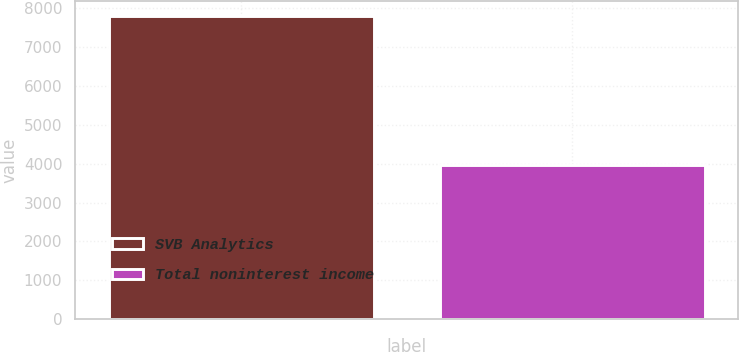Convert chart to OTSL. <chart><loc_0><loc_0><loc_500><loc_500><bar_chart><fcel>SVB Analytics<fcel>Total noninterest income<nl><fcel>7809<fcel>3961<nl></chart> 